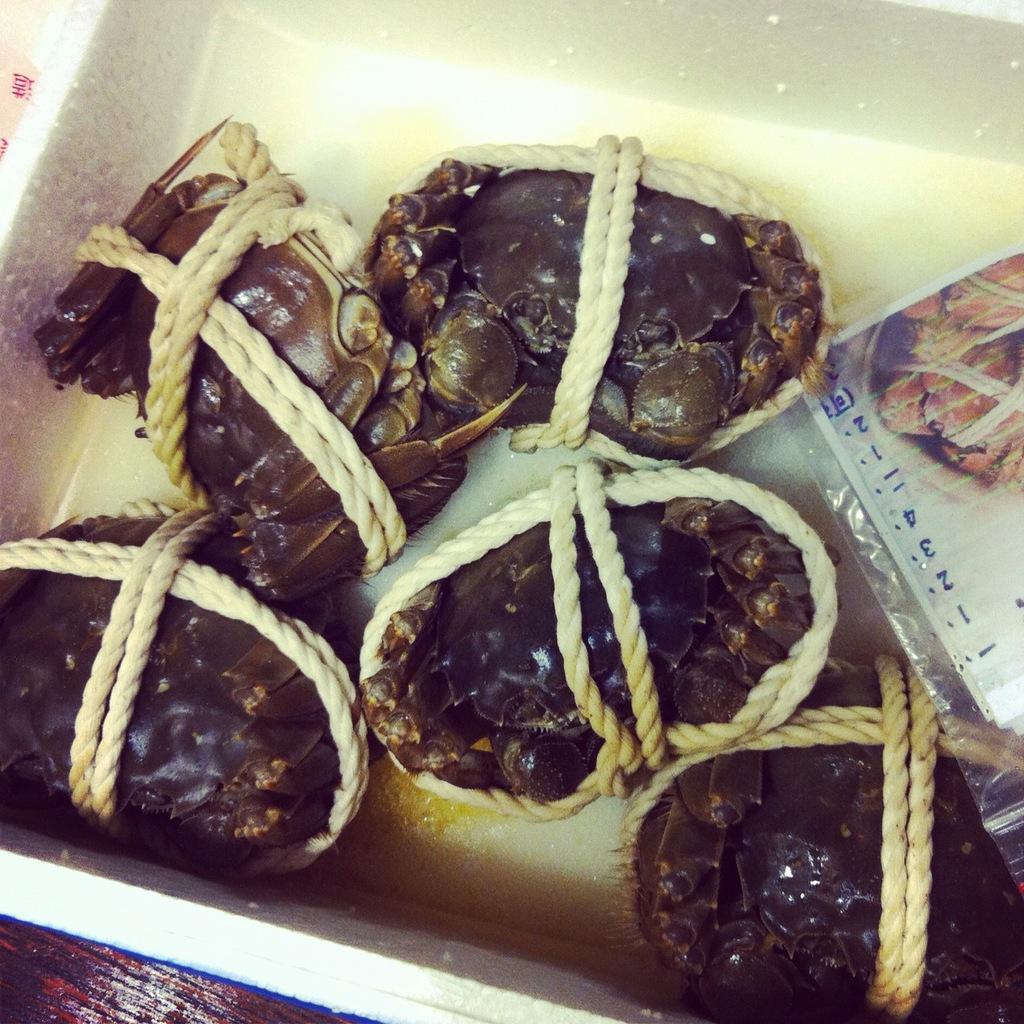Please provide a concise description of this image. In this image there are some crabs tied with rope and kept in a basket beside that there is a paper. 